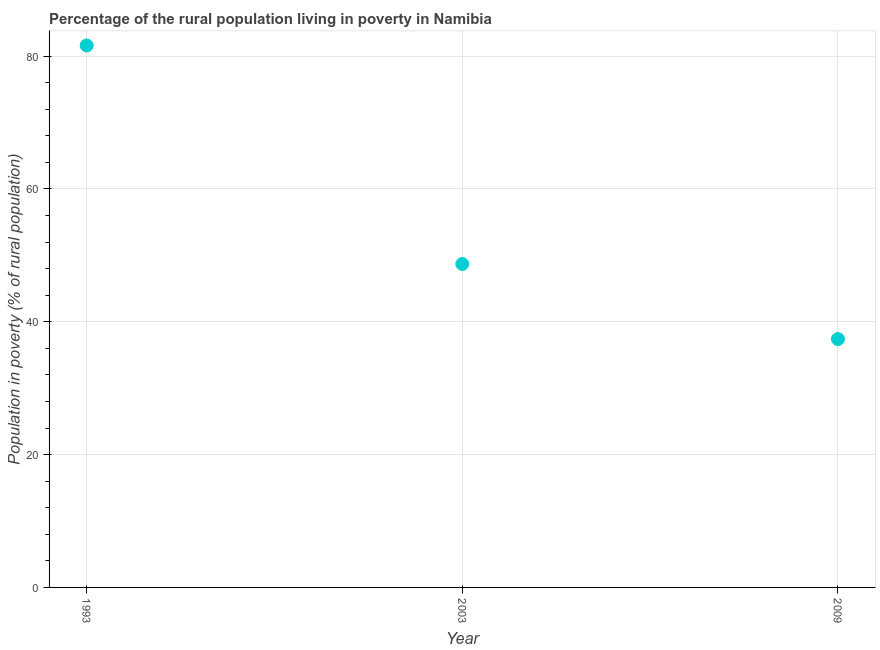What is the percentage of rural population living below poverty line in 1993?
Provide a succinct answer. 81.6. Across all years, what is the maximum percentage of rural population living below poverty line?
Ensure brevity in your answer.  81.6. Across all years, what is the minimum percentage of rural population living below poverty line?
Your answer should be compact. 37.4. In which year was the percentage of rural population living below poverty line maximum?
Your answer should be very brief. 1993. What is the sum of the percentage of rural population living below poverty line?
Your answer should be compact. 167.7. What is the difference between the percentage of rural population living below poverty line in 2003 and 2009?
Offer a very short reply. 11.3. What is the average percentage of rural population living below poverty line per year?
Make the answer very short. 55.9. What is the median percentage of rural population living below poverty line?
Keep it short and to the point. 48.7. What is the ratio of the percentage of rural population living below poverty line in 1993 to that in 2003?
Provide a succinct answer. 1.68. What is the difference between the highest and the second highest percentage of rural population living below poverty line?
Your response must be concise. 32.9. What is the difference between the highest and the lowest percentage of rural population living below poverty line?
Offer a terse response. 44.2. In how many years, is the percentage of rural population living below poverty line greater than the average percentage of rural population living below poverty line taken over all years?
Provide a short and direct response. 1. Does the percentage of rural population living below poverty line monotonically increase over the years?
Provide a short and direct response. No. How many dotlines are there?
Provide a short and direct response. 1. How many years are there in the graph?
Ensure brevity in your answer.  3. What is the difference between two consecutive major ticks on the Y-axis?
Give a very brief answer. 20. Are the values on the major ticks of Y-axis written in scientific E-notation?
Keep it short and to the point. No. Does the graph contain grids?
Offer a terse response. Yes. What is the title of the graph?
Offer a very short reply. Percentage of the rural population living in poverty in Namibia. What is the label or title of the X-axis?
Provide a short and direct response. Year. What is the label or title of the Y-axis?
Give a very brief answer. Population in poverty (% of rural population). What is the Population in poverty (% of rural population) in 1993?
Provide a short and direct response. 81.6. What is the Population in poverty (% of rural population) in 2003?
Ensure brevity in your answer.  48.7. What is the Population in poverty (% of rural population) in 2009?
Make the answer very short. 37.4. What is the difference between the Population in poverty (% of rural population) in 1993 and 2003?
Offer a terse response. 32.9. What is the difference between the Population in poverty (% of rural population) in 1993 and 2009?
Your response must be concise. 44.2. What is the difference between the Population in poverty (% of rural population) in 2003 and 2009?
Give a very brief answer. 11.3. What is the ratio of the Population in poverty (% of rural population) in 1993 to that in 2003?
Provide a short and direct response. 1.68. What is the ratio of the Population in poverty (% of rural population) in 1993 to that in 2009?
Your response must be concise. 2.18. What is the ratio of the Population in poverty (% of rural population) in 2003 to that in 2009?
Provide a short and direct response. 1.3. 